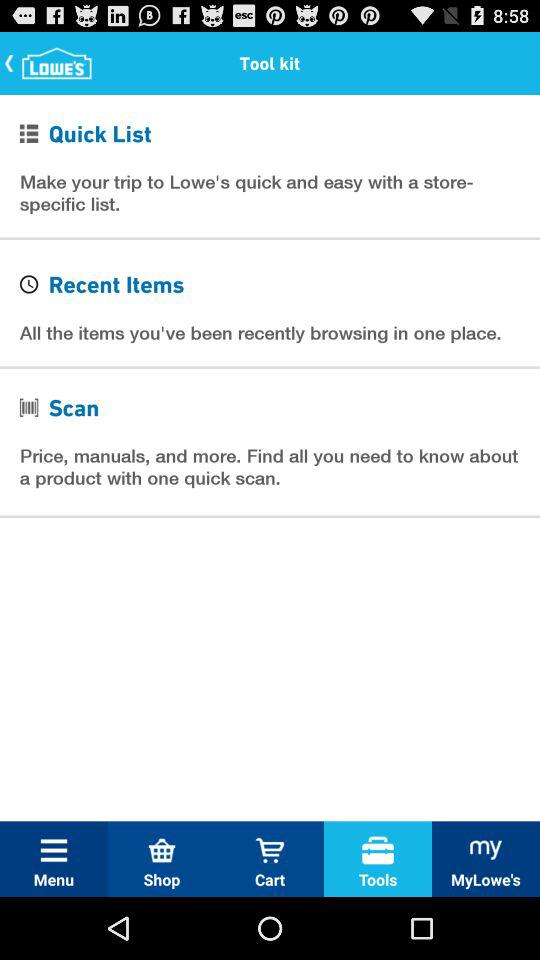Which tab is selected? The selected tab is tools. 